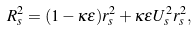Convert formula to latex. <formula><loc_0><loc_0><loc_500><loc_500>R ^ { 2 } _ { s } = ( 1 - \kappa \epsilon ) r ^ { 2 } _ { s } + \kappa \epsilon U ^ { 2 } _ { s } r ^ { 2 } _ { s } ,</formula> 